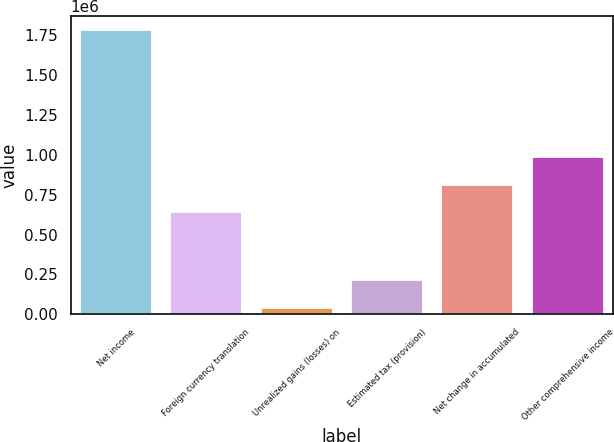Convert chart. <chart><loc_0><loc_0><loc_500><loc_500><bar_chart><fcel>Net income<fcel>Foreign currency translation<fcel>Unrealized gains (losses) on<fcel>Estimated tax (provision)<fcel>Net change in accumulated<fcel>Other comprehensive income<nl><fcel>1.77947e+06<fcel>638066<fcel>40522<fcel>214417<fcel>811961<fcel>985857<nl></chart> 